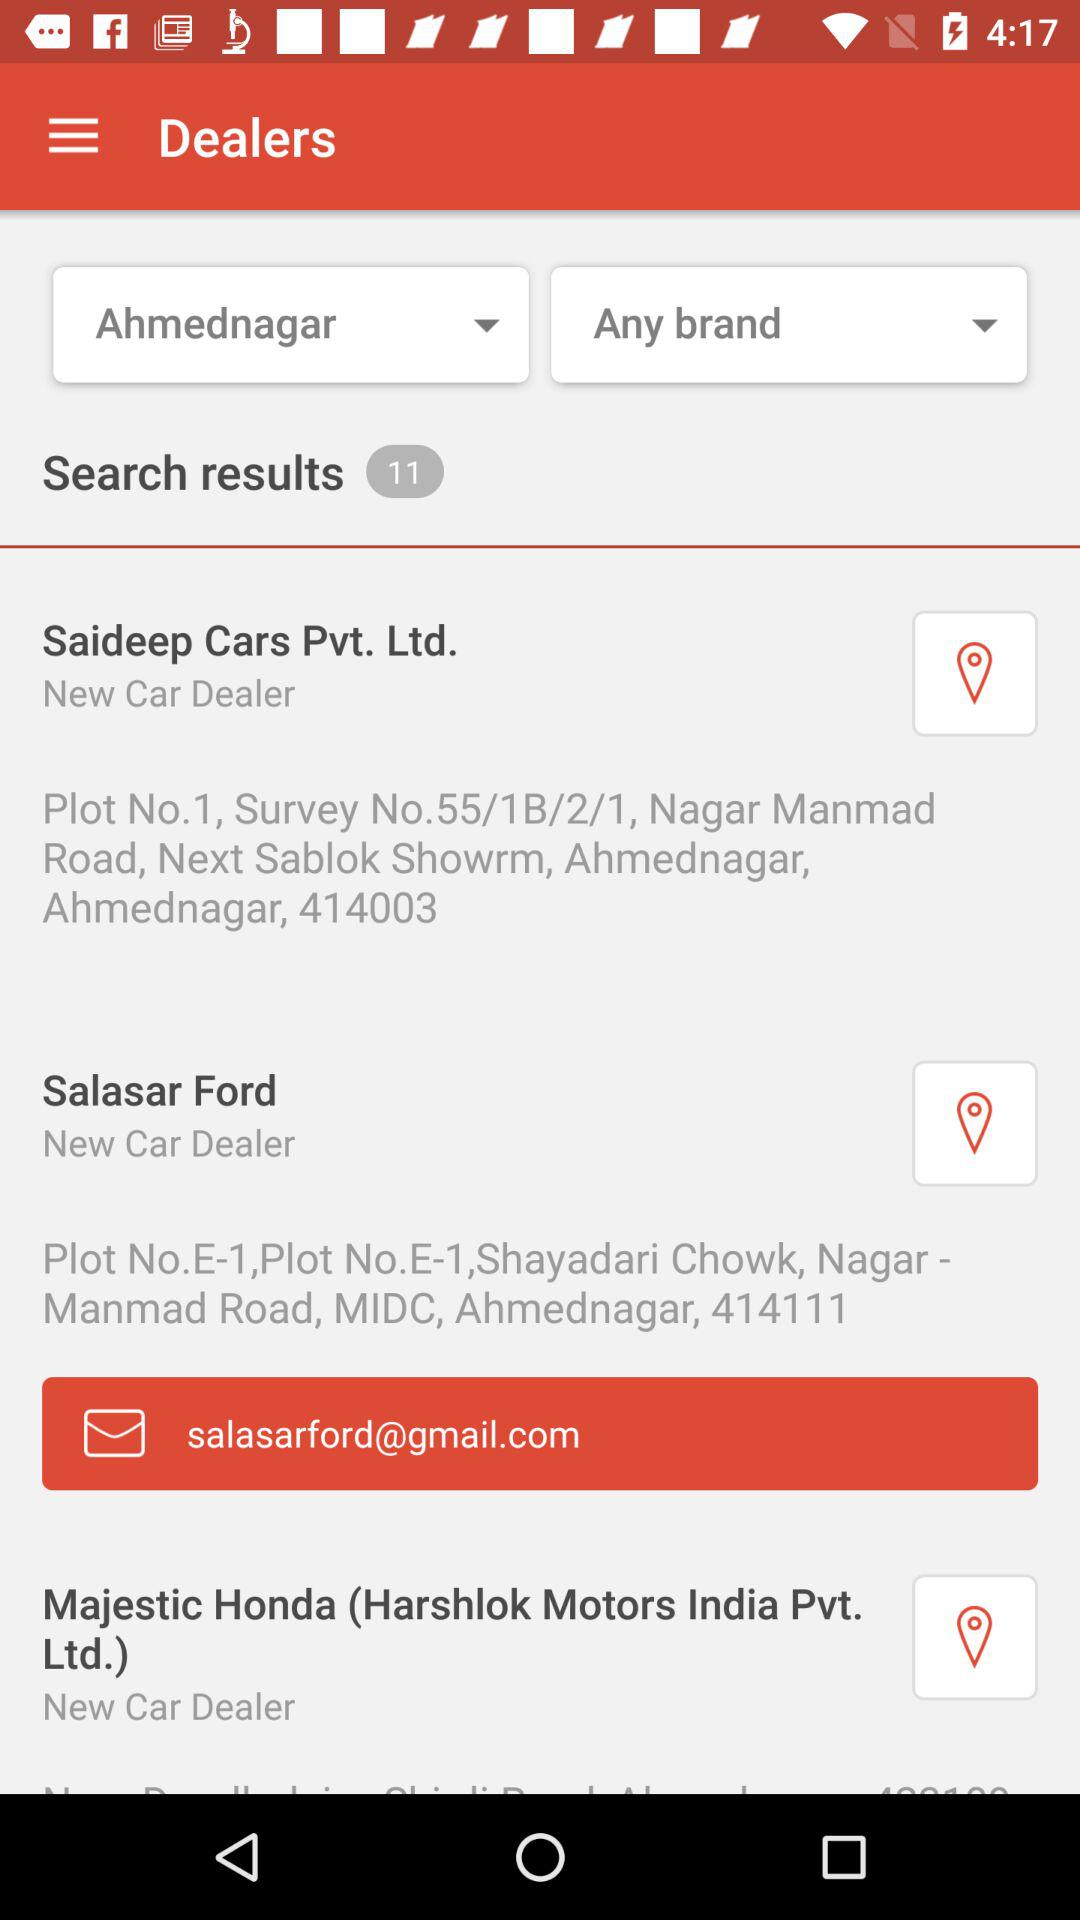What's the Gmail address? The Gmail address is salasarford@gmail.com. 